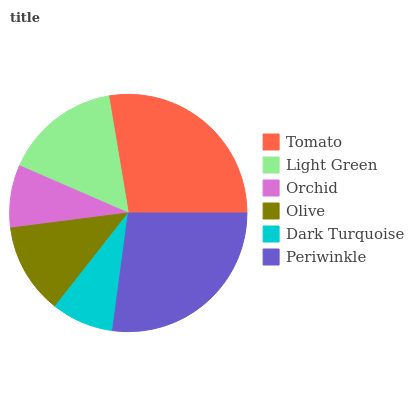Is Dark Turquoise the minimum?
Answer yes or no. Yes. Is Tomato the maximum?
Answer yes or no. Yes. Is Light Green the minimum?
Answer yes or no. No. Is Light Green the maximum?
Answer yes or no. No. Is Tomato greater than Light Green?
Answer yes or no. Yes. Is Light Green less than Tomato?
Answer yes or no. Yes. Is Light Green greater than Tomato?
Answer yes or no. No. Is Tomato less than Light Green?
Answer yes or no. No. Is Light Green the high median?
Answer yes or no. Yes. Is Olive the low median?
Answer yes or no. Yes. Is Orchid the high median?
Answer yes or no. No. Is Tomato the low median?
Answer yes or no. No. 